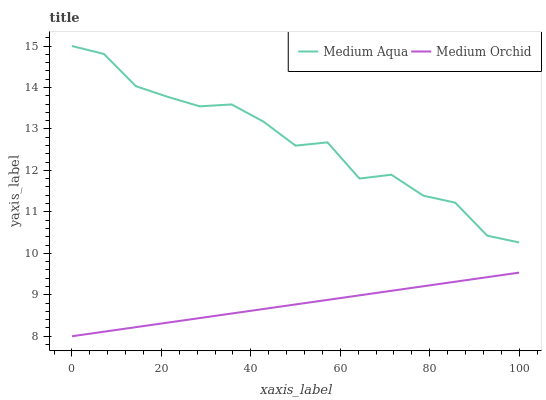Does Medium Orchid have the minimum area under the curve?
Answer yes or no. Yes. Does Medium Aqua have the maximum area under the curve?
Answer yes or no. Yes. Does Medium Aqua have the minimum area under the curve?
Answer yes or no. No. Is Medium Orchid the smoothest?
Answer yes or no. Yes. Is Medium Aqua the roughest?
Answer yes or no. Yes. Is Medium Aqua the smoothest?
Answer yes or no. No. Does Medium Orchid have the lowest value?
Answer yes or no. Yes. Does Medium Aqua have the lowest value?
Answer yes or no. No. Does Medium Aqua have the highest value?
Answer yes or no. Yes. Is Medium Orchid less than Medium Aqua?
Answer yes or no. Yes. Is Medium Aqua greater than Medium Orchid?
Answer yes or no. Yes. Does Medium Orchid intersect Medium Aqua?
Answer yes or no. No. 